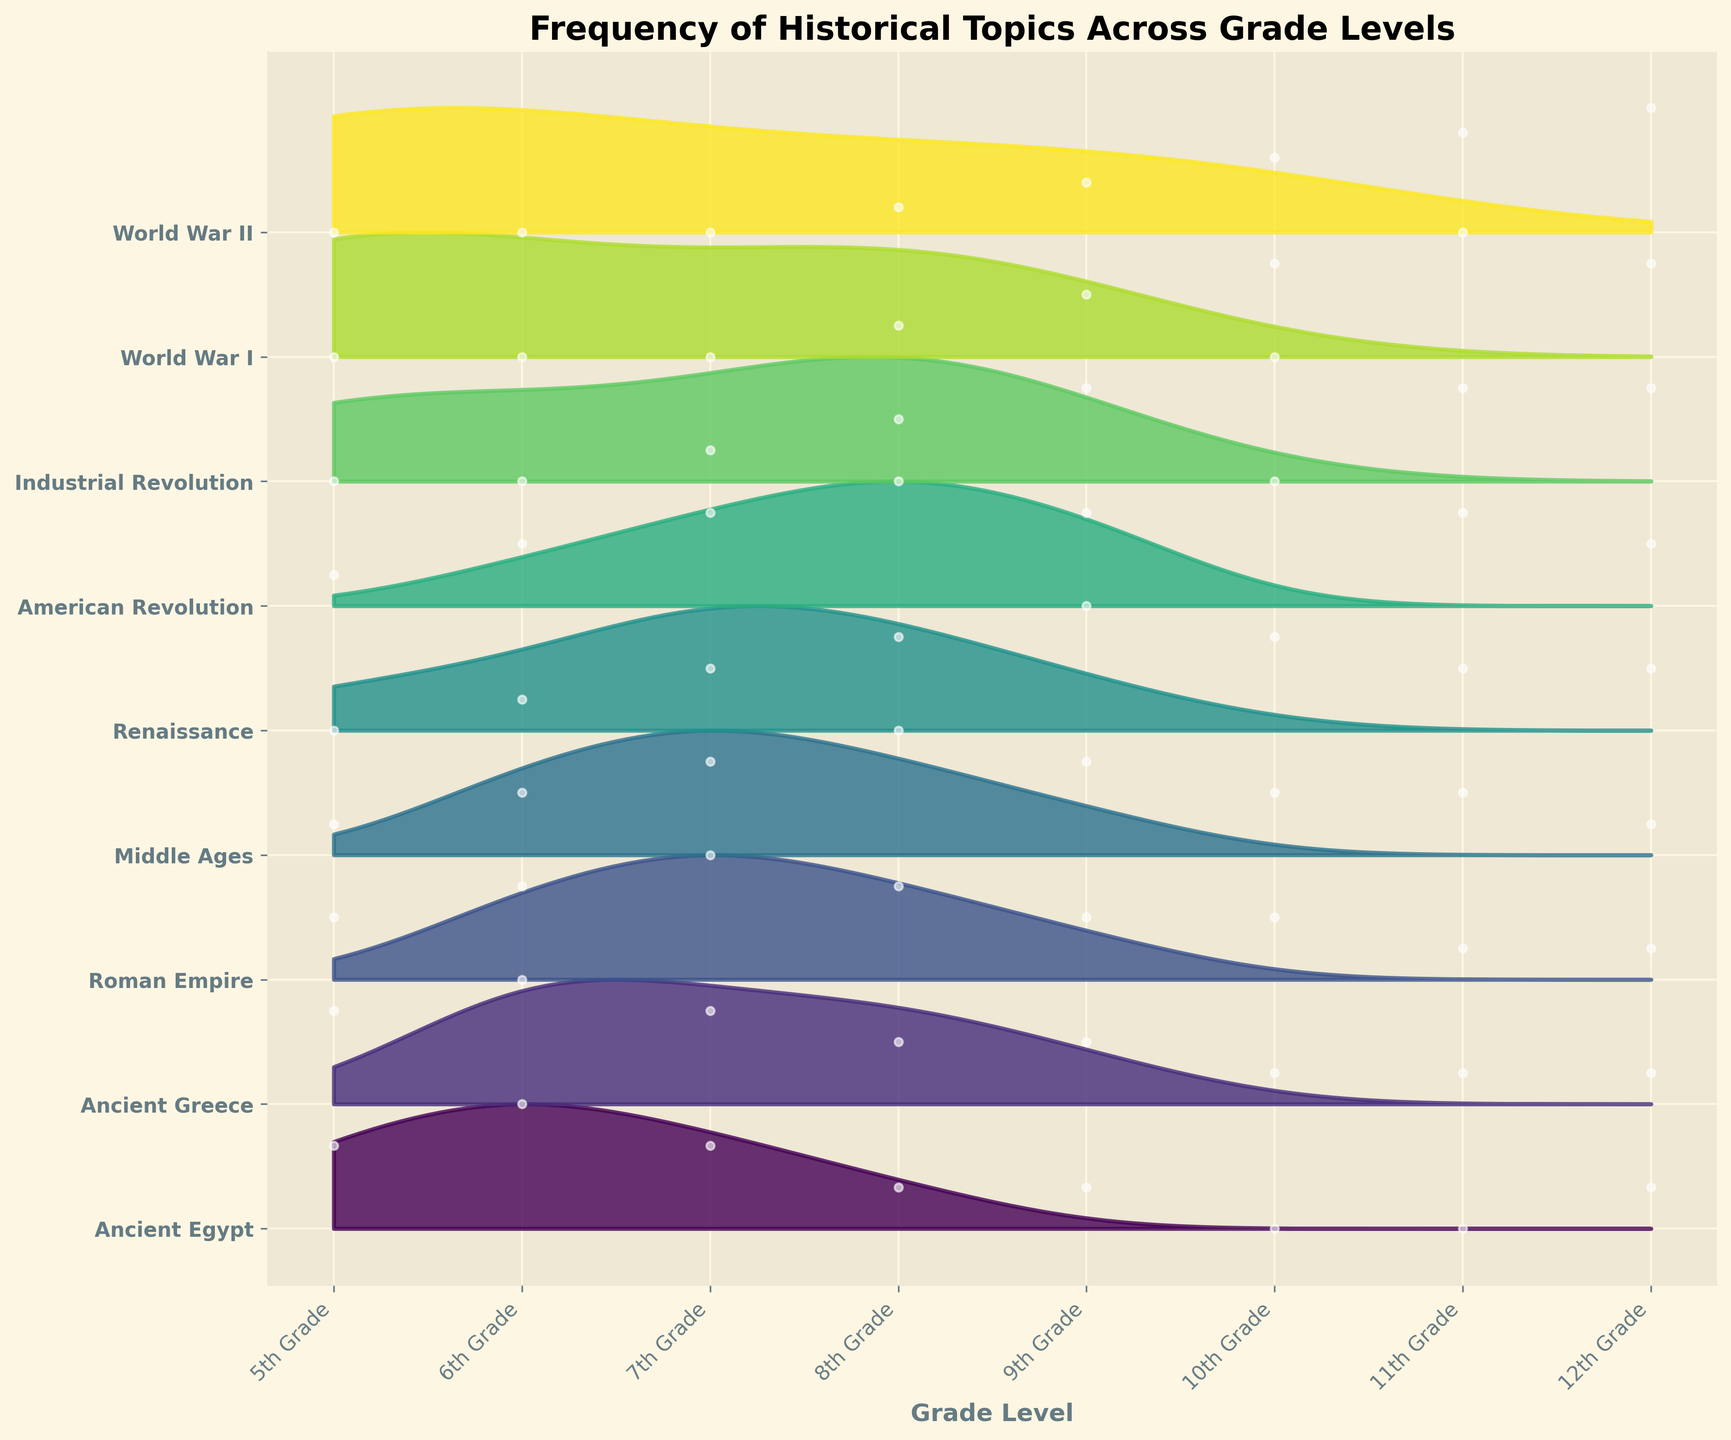What is the title of the plot? The title is usually positioned at the top center of the plot and designed to give a concise summary of what the plot is about. For this plot, it summarizes the focus on frequencies of historical topics over various grades.
Answer: Frequency of Historical Topics Across Grade Levels Which grade levels cover the topic "World War II"? The ridgeline plot indicates frequency along the x-axis and topics along the y-axis. By following the line and looking for "World War II," we see bands or fills in the upper grades.
Answer: 8th to 12th Grades In which grade is the frequency of "Renaissance" the highest? By observing the plot, look towards the "Renaissance" category and notice the highest peak in its curve or filled color area among different grades.
Answer: 9th Grade Compare the frequencies of "Ancient Greece" and "Middle Ages" in the 6th Grade. Which one is higher? Examine the plot specifically in the 6th Grade column and visually compare the heights of the curves or areas for "Ancient Greece" and "Middle Ages."
Answer: Ancient Greece Which historical topic shows a steady increase in frequency from 5th to 12th Grade? By observing the ridgeline plot across grades, look for a topic whose curve or color area consistently rises without much fluctuation.
Answer: World War II Which two historical topics have equal frequency in 10th Grade? Focus on the 10th Grade column and find topics where the heights of the curves or filled areas are identical.
Answer: Middle Ages and Ancient Greece What is the combined frequency of "American Revolution" in the 5th and 6th Grades? Sum the heights of the filled areas for "American Revolution" in both 5th and 6th Grade columns.
Answer: 3 What is the most frequently covered topic in 7th Grade? Check the 7th Grade column and identify the topic with the highest peak or largest filled area.
Answer: Roman Empire Among the topics "Industrial Revolution" and "World War I," which one sees a more consistent increase across grades? Compare both topics by following their curves from 5th to 12th Grades and determine which has a smoother, upward trend.
Answer: Industrial Revolution Which topic is least frequently covered in 12th Grade? Look at the 12th Grade column and identify the topic with the smallest peak or least filled area.
Answer: Ancient Egypt 